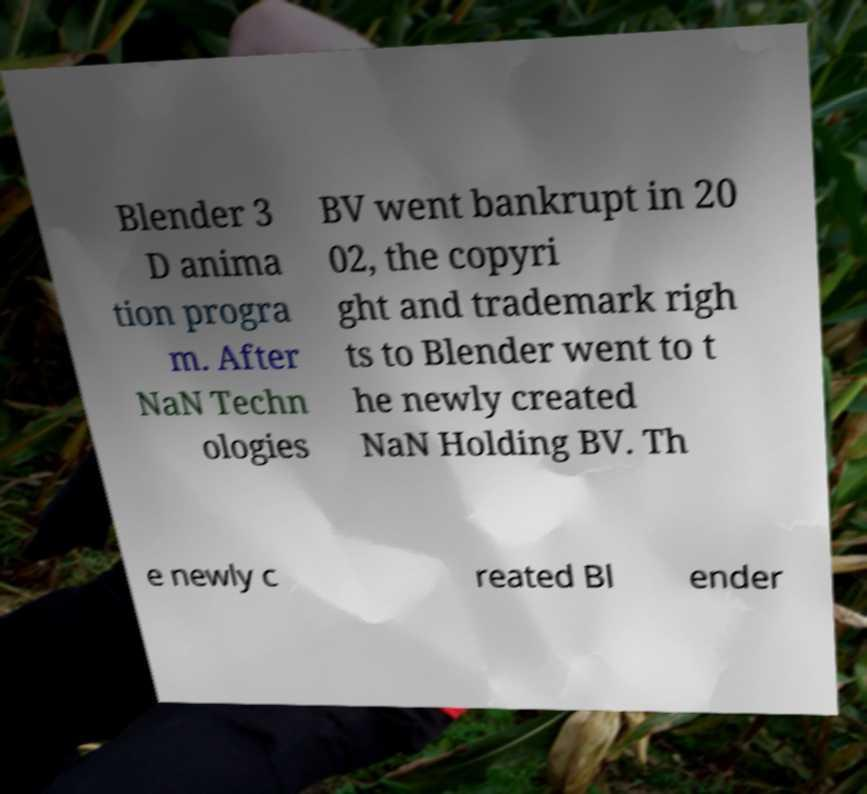What messages or text are displayed in this image? I need them in a readable, typed format. Blender 3 D anima tion progra m. After NaN Techn ologies BV went bankrupt in 20 02, the copyri ght and trademark righ ts to Blender went to t he newly created NaN Holding BV. Th e newly c reated Bl ender 